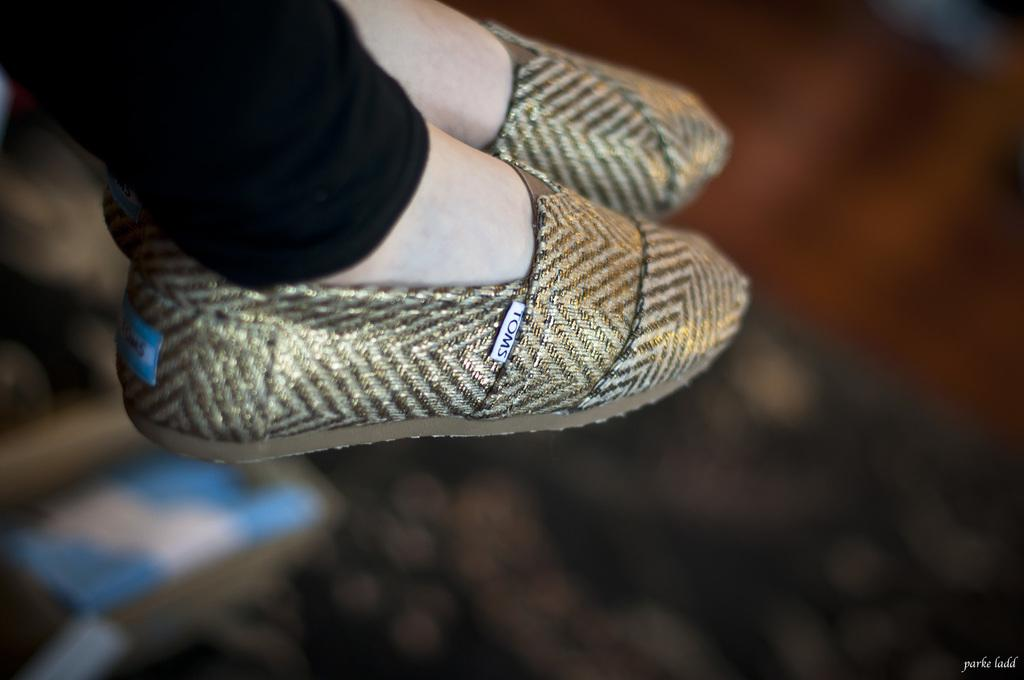What part of a person's body can be seen in the image? A person's legs are visible in the image. What is the person wearing on their feet? The person is wearing footwear. Can you describe the background of the image? The background of the image is blurry. What type of bread can be seen in the person's hand in the image? There is no bread present in the image; only the person's legs and footwear are visible. 